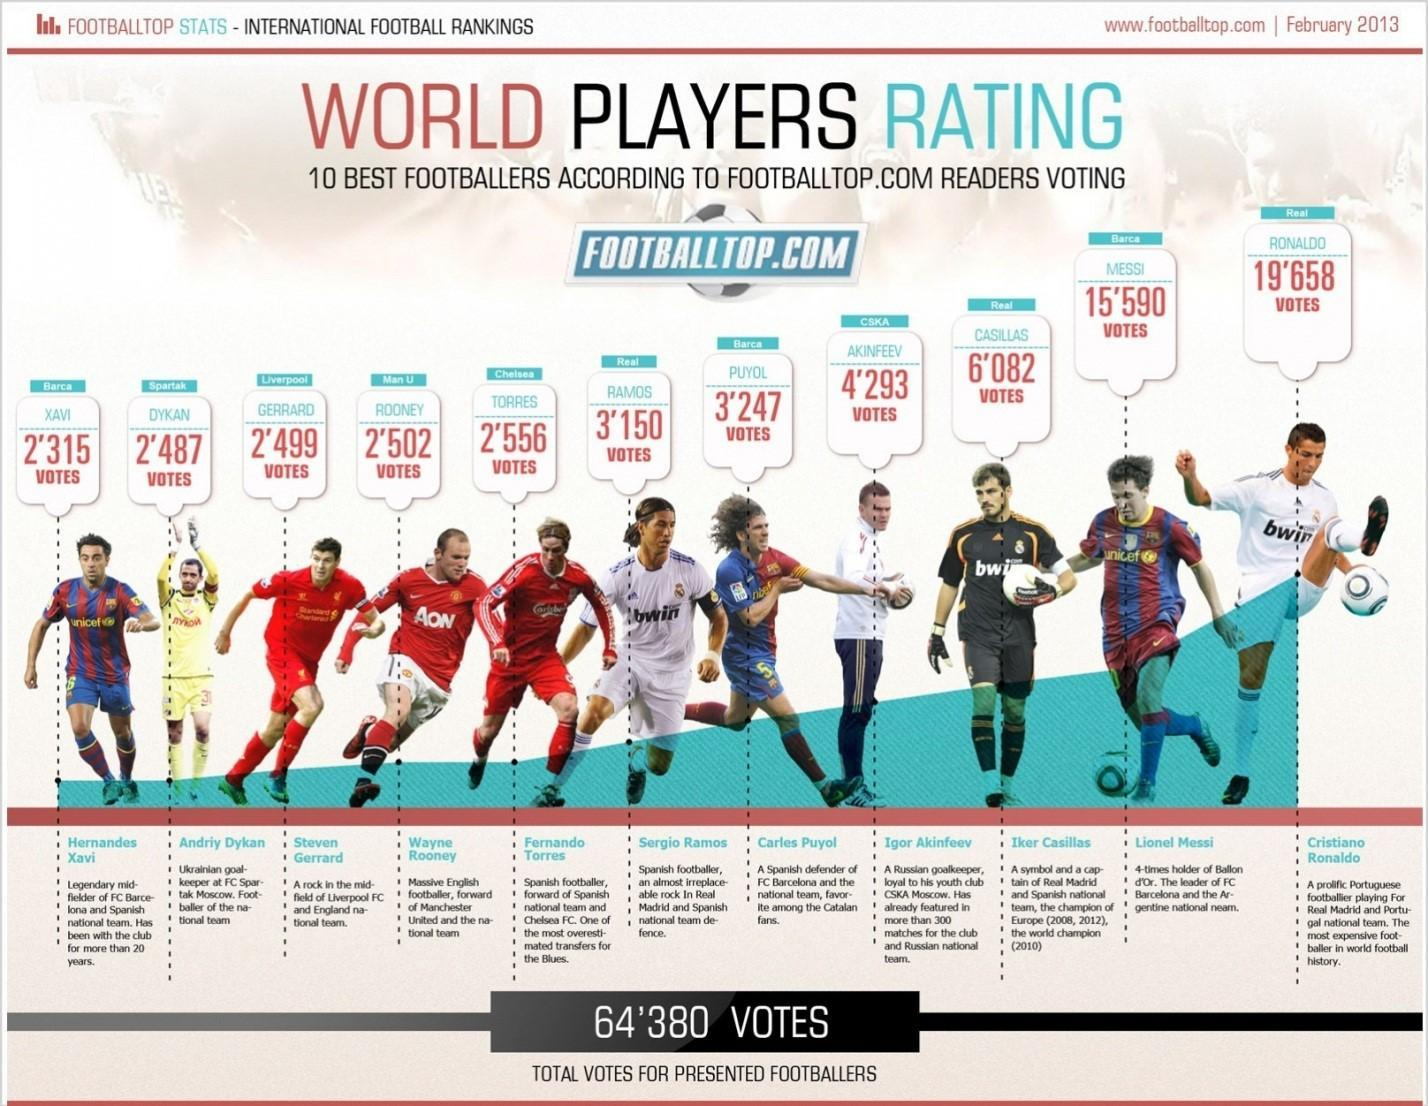which footballer is in yellow shirt
Answer the question with a short phrase. Andriy Dykan What is the difference in votes between the top 2 4068 how many footballers are in red shirt 3 Which teams do Wayne Rooney belong to Manchester United and the National team what is the dress colour of Ronaldo, white or red white Which united nation organisation name is written on the t shirt of Xavi unicef What is Casillas holding in his hand, football or bat football Who is rated immediately below Messi Casillas 